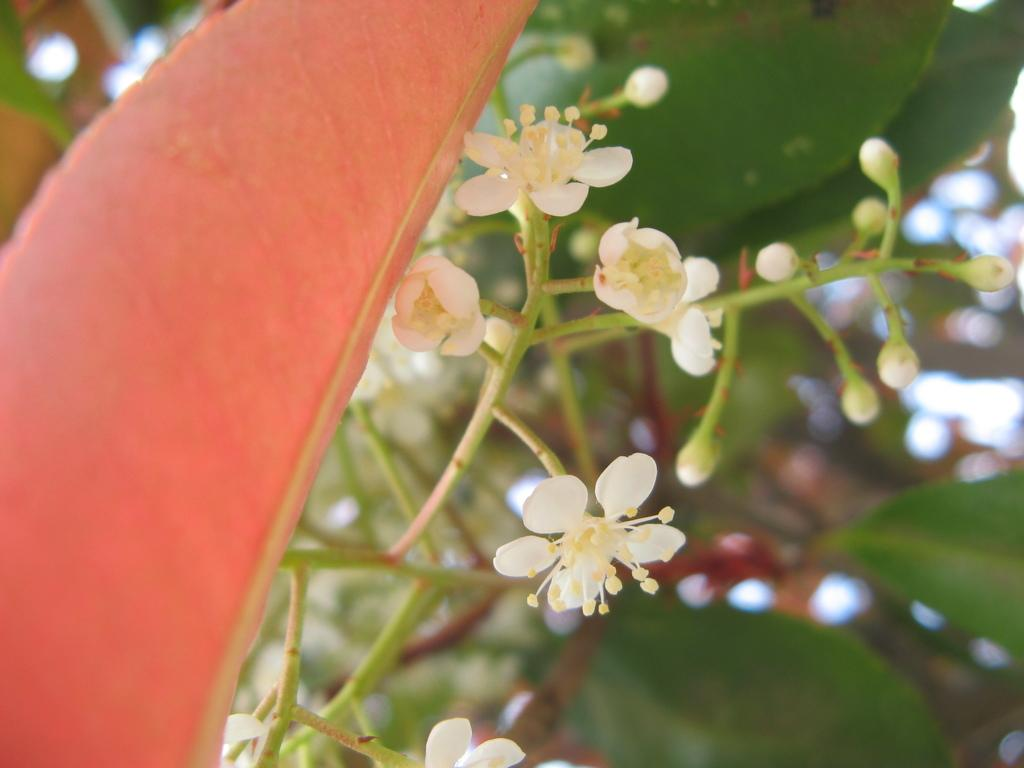What type of living organisms can be seen in the image? There are flowers and plants visible in the image. Can you describe the object on the left side of the image? Unfortunately, the provided facts do not give any information about the object on the left side of the image. What is the condition of the background in the image? The background of the image is blurred. How many men are blowing cherries in the image? There are no men or cherries present in the image. 